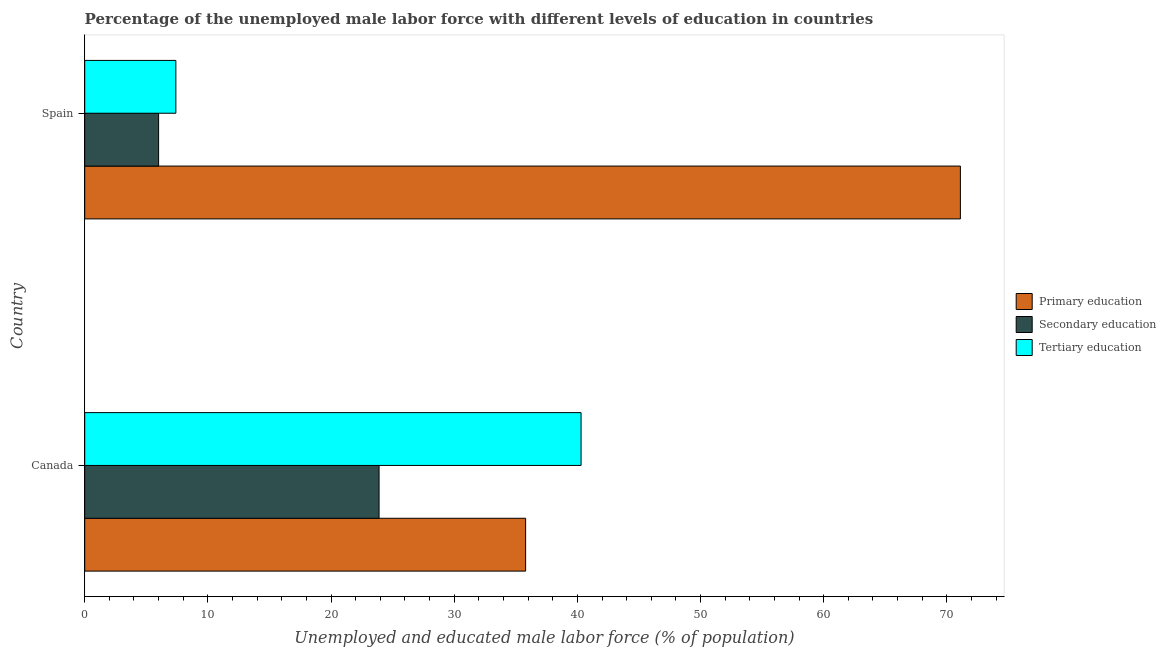How many different coloured bars are there?
Offer a terse response. 3. How many groups of bars are there?
Provide a short and direct response. 2. Are the number of bars on each tick of the Y-axis equal?
Keep it short and to the point. Yes. How many bars are there on the 2nd tick from the top?
Your answer should be very brief. 3. How many bars are there on the 2nd tick from the bottom?
Provide a short and direct response. 3. In how many cases, is the number of bars for a given country not equal to the number of legend labels?
Your response must be concise. 0. What is the percentage of male labor force who received secondary education in Spain?
Provide a succinct answer. 6. Across all countries, what is the maximum percentage of male labor force who received primary education?
Give a very brief answer. 71.1. Across all countries, what is the minimum percentage of male labor force who received primary education?
Ensure brevity in your answer.  35.8. In which country was the percentage of male labor force who received secondary education maximum?
Your answer should be compact. Canada. In which country was the percentage of male labor force who received secondary education minimum?
Offer a terse response. Spain. What is the total percentage of male labor force who received tertiary education in the graph?
Offer a terse response. 47.7. What is the difference between the percentage of male labor force who received tertiary education in Canada and that in Spain?
Your answer should be compact. 32.9. What is the difference between the percentage of male labor force who received primary education in Canada and the percentage of male labor force who received tertiary education in Spain?
Your response must be concise. 28.4. What is the average percentage of male labor force who received primary education per country?
Give a very brief answer. 53.45. What is the difference between the percentage of male labor force who received tertiary education and percentage of male labor force who received secondary education in Canada?
Provide a succinct answer. 16.4. In how many countries, is the percentage of male labor force who received secondary education greater than 30 %?
Ensure brevity in your answer.  0. What is the ratio of the percentage of male labor force who received primary education in Canada to that in Spain?
Make the answer very short. 0.5. Is the percentage of male labor force who received tertiary education in Canada less than that in Spain?
Your response must be concise. No. Is the difference between the percentage of male labor force who received tertiary education in Canada and Spain greater than the difference between the percentage of male labor force who received primary education in Canada and Spain?
Your answer should be compact. Yes. What does the 3rd bar from the top in Canada represents?
Your answer should be compact. Primary education. How many bars are there?
Provide a short and direct response. 6. Are all the bars in the graph horizontal?
Provide a short and direct response. Yes. How many countries are there in the graph?
Your response must be concise. 2. What is the difference between two consecutive major ticks on the X-axis?
Provide a succinct answer. 10. Where does the legend appear in the graph?
Provide a succinct answer. Center right. How are the legend labels stacked?
Provide a succinct answer. Vertical. What is the title of the graph?
Make the answer very short. Percentage of the unemployed male labor force with different levels of education in countries. Does "Spain" appear as one of the legend labels in the graph?
Keep it short and to the point. No. What is the label or title of the X-axis?
Your answer should be very brief. Unemployed and educated male labor force (% of population). What is the Unemployed and educated male labor force (% of population) in Primary education in Canada?
Provide a short and direct response. 35.8. What is the Unemployed and educated male labor force (% of population) in Secondary education in Canada?
Ensure brevity in your answer.  23.9. What is the Unemployed and educated male labor force (% of population) of Tertiary education in Canada?
Your answer should be very brief. 40.3. What is the Unemployed and educated male labor force (% of population) of Primary education in Spain?
Provide a short and direct response. 71.1. What is the Unemployed and educated male labor force (% of population) in Secondary education in Spain?
Ensure brevity in your answer.  6. What is the Unemployed and educated male labor force (% of population) in Tertiary education in Spain?
Your response must be concise. 7.4. Across all countries, what is the maximum Unemployed and educated male labor force (% of population) in Primary education?
Offer a terse response. 71.1. Across all countries, what is the maximum Unemployed and educated male labor force (% of population) in Secondary education?
Offer a very short reply. 23.9. Across all countries, what is the maximum Unemployed and educated male labor force (% of population) in Tertiary education?
Offer a terse response. 40.3. Across all countries, what is the minimum Unemployed and educated male labor force (% of population) in Primary education?
Provide a succinct answer. 35.8. Across all countries, what is the minimum Unemployed and educated male labor force (% of population) in Secondary education?
Provide a short and direct response. 6. Across all countries, what is the minimum Unemployed and educated male labor force (% of population) of Tertiary education?
Provide a succinct answer. 7.4. What is the total Unemployed and educated male labor force (% of population) of Primary education in the graph?
Offer a very short reply. 106.9. What is the total Unemployed and educated male labor force (% of population) in Secondary education in the graph?
Ensure brevity in your answer.  29.9. What is the total Unemployed and educated male labor force (% of population) of Tertiary education in the graph?
Provide a succinct answer. 47.7. What is the difference between the Unemployed and educated male labor force (% of population) of Primary education in Canada and that in Spain?
Give a very brief answer. -35.3. What is the difference between the Unemployed and educated male labor force (% of population) of Secondary education in Canada and that in Spain?
Offer a very short reply. 17.9. What is the difference between the Unemployed and educated male labor force (% of population) in Tertiary education in Canada and that in Spain?
Give a very brief answer. 32.9. What is the difference between the Unemployed and educated male labor force (% of population) of Primary education in Canada and the Unemployed and educated male labor force (% of population) of Secondary education in Spain?
Provide a short and direct response. 29.8. What is the difference between the Unemployed and educated male labor force (% of population) of Primary education in Canada and the Unemployed and educated male labor force (% of population) of Tertiary education in Spain?
Your answer should be very brief. 28.4. What is the average Unemployed and educated male labor force (% of population) in Primary education per country?
Your response must be concise. 53.45. What is the average Unemployed and educated male labor force (% of population) of Secondary education per country?
Provide a succinct answer. 14.95. What is the average Unemployed and educated male labor force (% of population) in Tertiary education per country?
Offer a terse response. 23.85. What is the difference between the Unemployed and educated male labor force (% of population) in Secondary education and Unemployed and educated male labor force (% of population) in Tertiary education in Canada?
Provide a short and direct response. -16.4. What is the difference between the Unemployed and educated male labor force (% of population) of Primary education and Unemployed and educated male labor force (% of population) of Secondary education in Spain?
Your answer should be very brief. 65.1. What is the difference between the Unemployed and educated male labor force (% of population) in Primary education and Unemployed and educated male labor force (% of population) in Tertiary education in Spain?
Keep it short and to the point. 63.7. What is the difference between the Unemployed and educated male labor force (% of population) of Secondary education and Unemployed and educated male labor force (% of population) of Tertiary education in Spain?
Make the answer very short. -1.4. What is the ratio of the Unemployed and educated male labor force (% of population) of Primary education in Canada to that in Spain?
Keep it short and to the point. 0.5. What is the ratio of the Unemployed and educated male labor force (% of population) of Secondary education in Canada to that in Spain?
Your answer should be very brief. 3.98. What is the ratio of the Unemployed and educated male labor force (% of population) in Tertiary education in Canada to that in Spain?
Your response must be concise. 5.45. What is the difference between the highest and the second highest Unemployed and educated male labor force (% of population) of Primary education?
Give a very brief answer. 35.3. What is the difference between the highest and the second highest Unemployed and educated male labor force (% of population) of Secondary education?
Offer a terse response. 17.9. What is the difference between the highest and the second highest Unemployed and educated male labor force (% of population) in Tertiary education?
Your answer should be compact. 32.9. What is the difference between the highest and the lowest Unemployed and educated male labor force (% of population) in Primary education?
Make the answer very short. 35.3. What is the difference between the highest and the lowest Unemployed and educated male labor force (% of population) in Secondary education?
Offer a very short reply. 17.9. What is the difference between the highest and the lowest Unemployed and educated male labor force (% of population) of Tertiary education?
Ensure brevity in your answer.  32.9. 